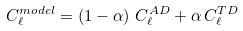Convert formula to latex. <formula><loc_0><loc_0><loc_500><loc_500>C _ { \ell } ^ { m o d e l } = \left ( 1 - \alpha \right ) \, C _ { \ell } ^ { A D } + \alpha \, C _ { \ell } ^ { T D }</formula> 